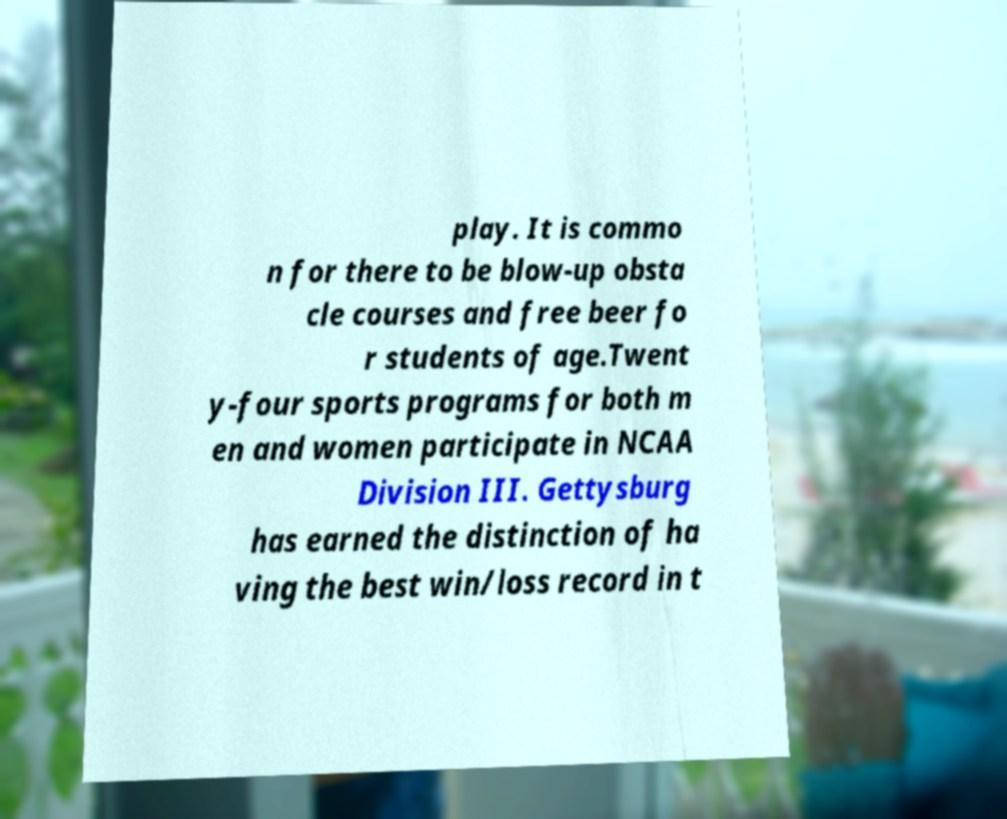There's text embedded in this image that I need extracted. Can you transcribe it verbatim? play. It is commo n for there to be blow-up obsta cle courses and free beer fo r students of age.Twent y-four sports programs for both m en and women participate in NCAA Division III. Gettysburg has earned the distinction of ha ving the best win/loss record in t 